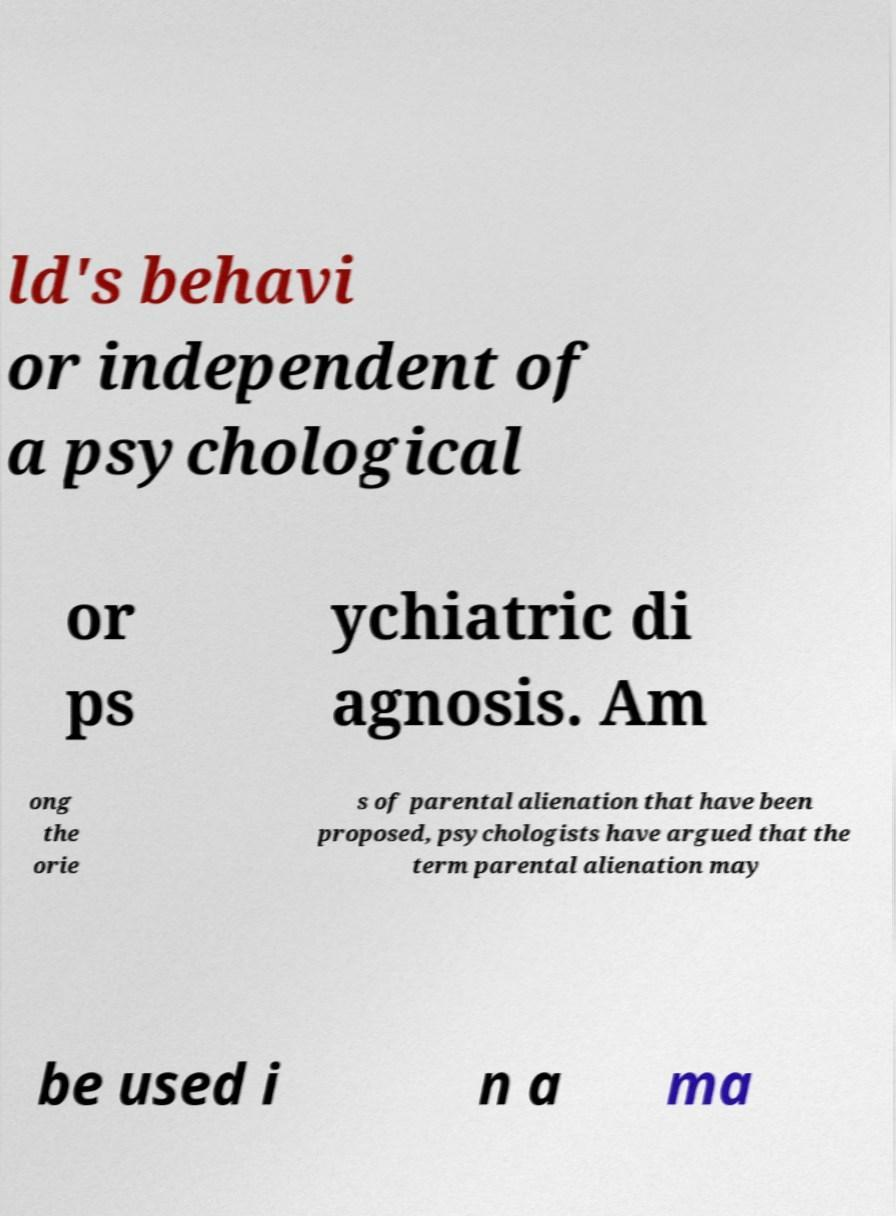Please identify and transcribe the text found in this image. ld's behavi or independent of a psychological or ps ychiatric di agnosis. Am ong the orie s of parental alienation that have been proposed, psychologists have argued that the term parental alienation may be used i n a ma 